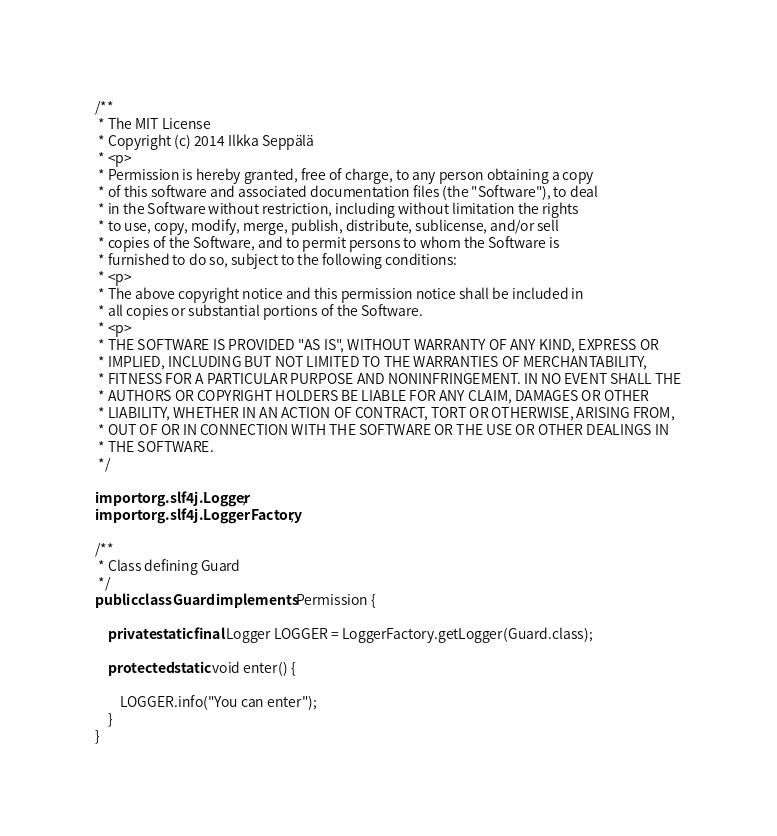Convert code to text. <code><loc_0><loc_0><loc_500><loc_500><_Java_>/**
 * The MIT License
 * Copyright (c) 2014 Ilkka Seppälä
 * <p>
 * Permission is hereby granted, free of charge, to any person obtaining a copy
 * of this software and associated documentation files (the "Software"), to deal
 * in the Software without restriction, including without limitation the rights
 * to use, copy, modify, merge, publish, distribute, sublicense, and/or sell
 * copies of the Software, and to permit persons to whom the Software is
 * furnished to do so, subject to the following conditions:
 * <p>
 * The above copyright notice and this permission notice shall be included in
 * all copies or substantial portions of the Software.
 * <p>
 * THE SOFTWARE IS PROVIDED "AS IS", WITHOUT WARRANTY OF ANY KIND, EXPRESS OR
 * IMPLIED, INCLUDING BUT NOT LIMITED TO THE WARRANTIES OF MERCHANTABILITY,
 * FITNESS FOR A PARTICULAR PURPOSE AND NONINFRINGEMENT. IN NO EVENT SHALL THE
 * AUTHORS OR COPYRIGHT HOLDERS BE LIABLE FOR ANY CLAIM, DAMAGES OR OTHER
 * LIABILITY, WHETHER IN AN ACTION OF CONTRACT, TORT OR OTHERWISE, ARISING FROM,
 * OUT OF OR IN CONNECTION WITH THE SOFTWARE OR THE USE OR OTHER DEALINGS IN
 * THE SOFTWARE.
 */

import org.slf4j.Logger;
import org.slf4j.LoggerFactory;

/**
 * Class defining Guard
 */
public class Guard implements Permission {

    private static final Logger LOGGER = LoggerFactory.getLogger(Guard.class);

    protected static void enter() {

        LOGGER.info("You can enter");
    }
}
</code> 